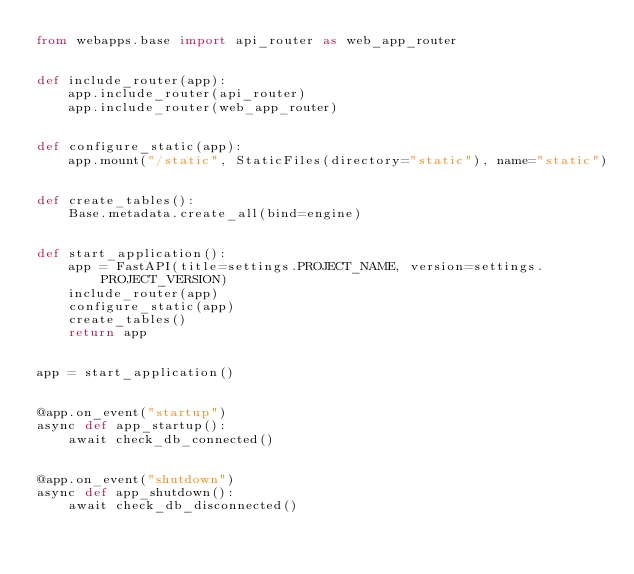<code> <loc_0><loc_0><loc_500><loc_500><_Python_>from webapps.base import api_router as web_app_router


def include_router(app):
    app.include_router(api_router)
    app.include_router(web_app_router)


def configure_static(app):
    app.mount("/static", StaticFiles(directory="static"), name="static")


def create_tables():
    Base.metadata.create_all(bind=engine)


def start_application():
    app = FastAPI(title=settings.PROJECT_NAME, version=settings.PROJECT_VERSION)
    include_router(app)
    configure_static(app)
    create_tables()
    return app


app = start_application()


@app.on_event("startup")
async def app_startup():
    await check_db_connected()


@app.on_event("shutdown")
async def app_shutdown():
    await check_db_disconnected()
</code> 